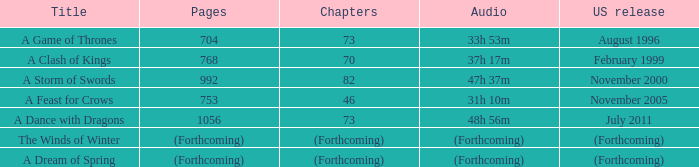Which US release has 704 pages? August 1996. 